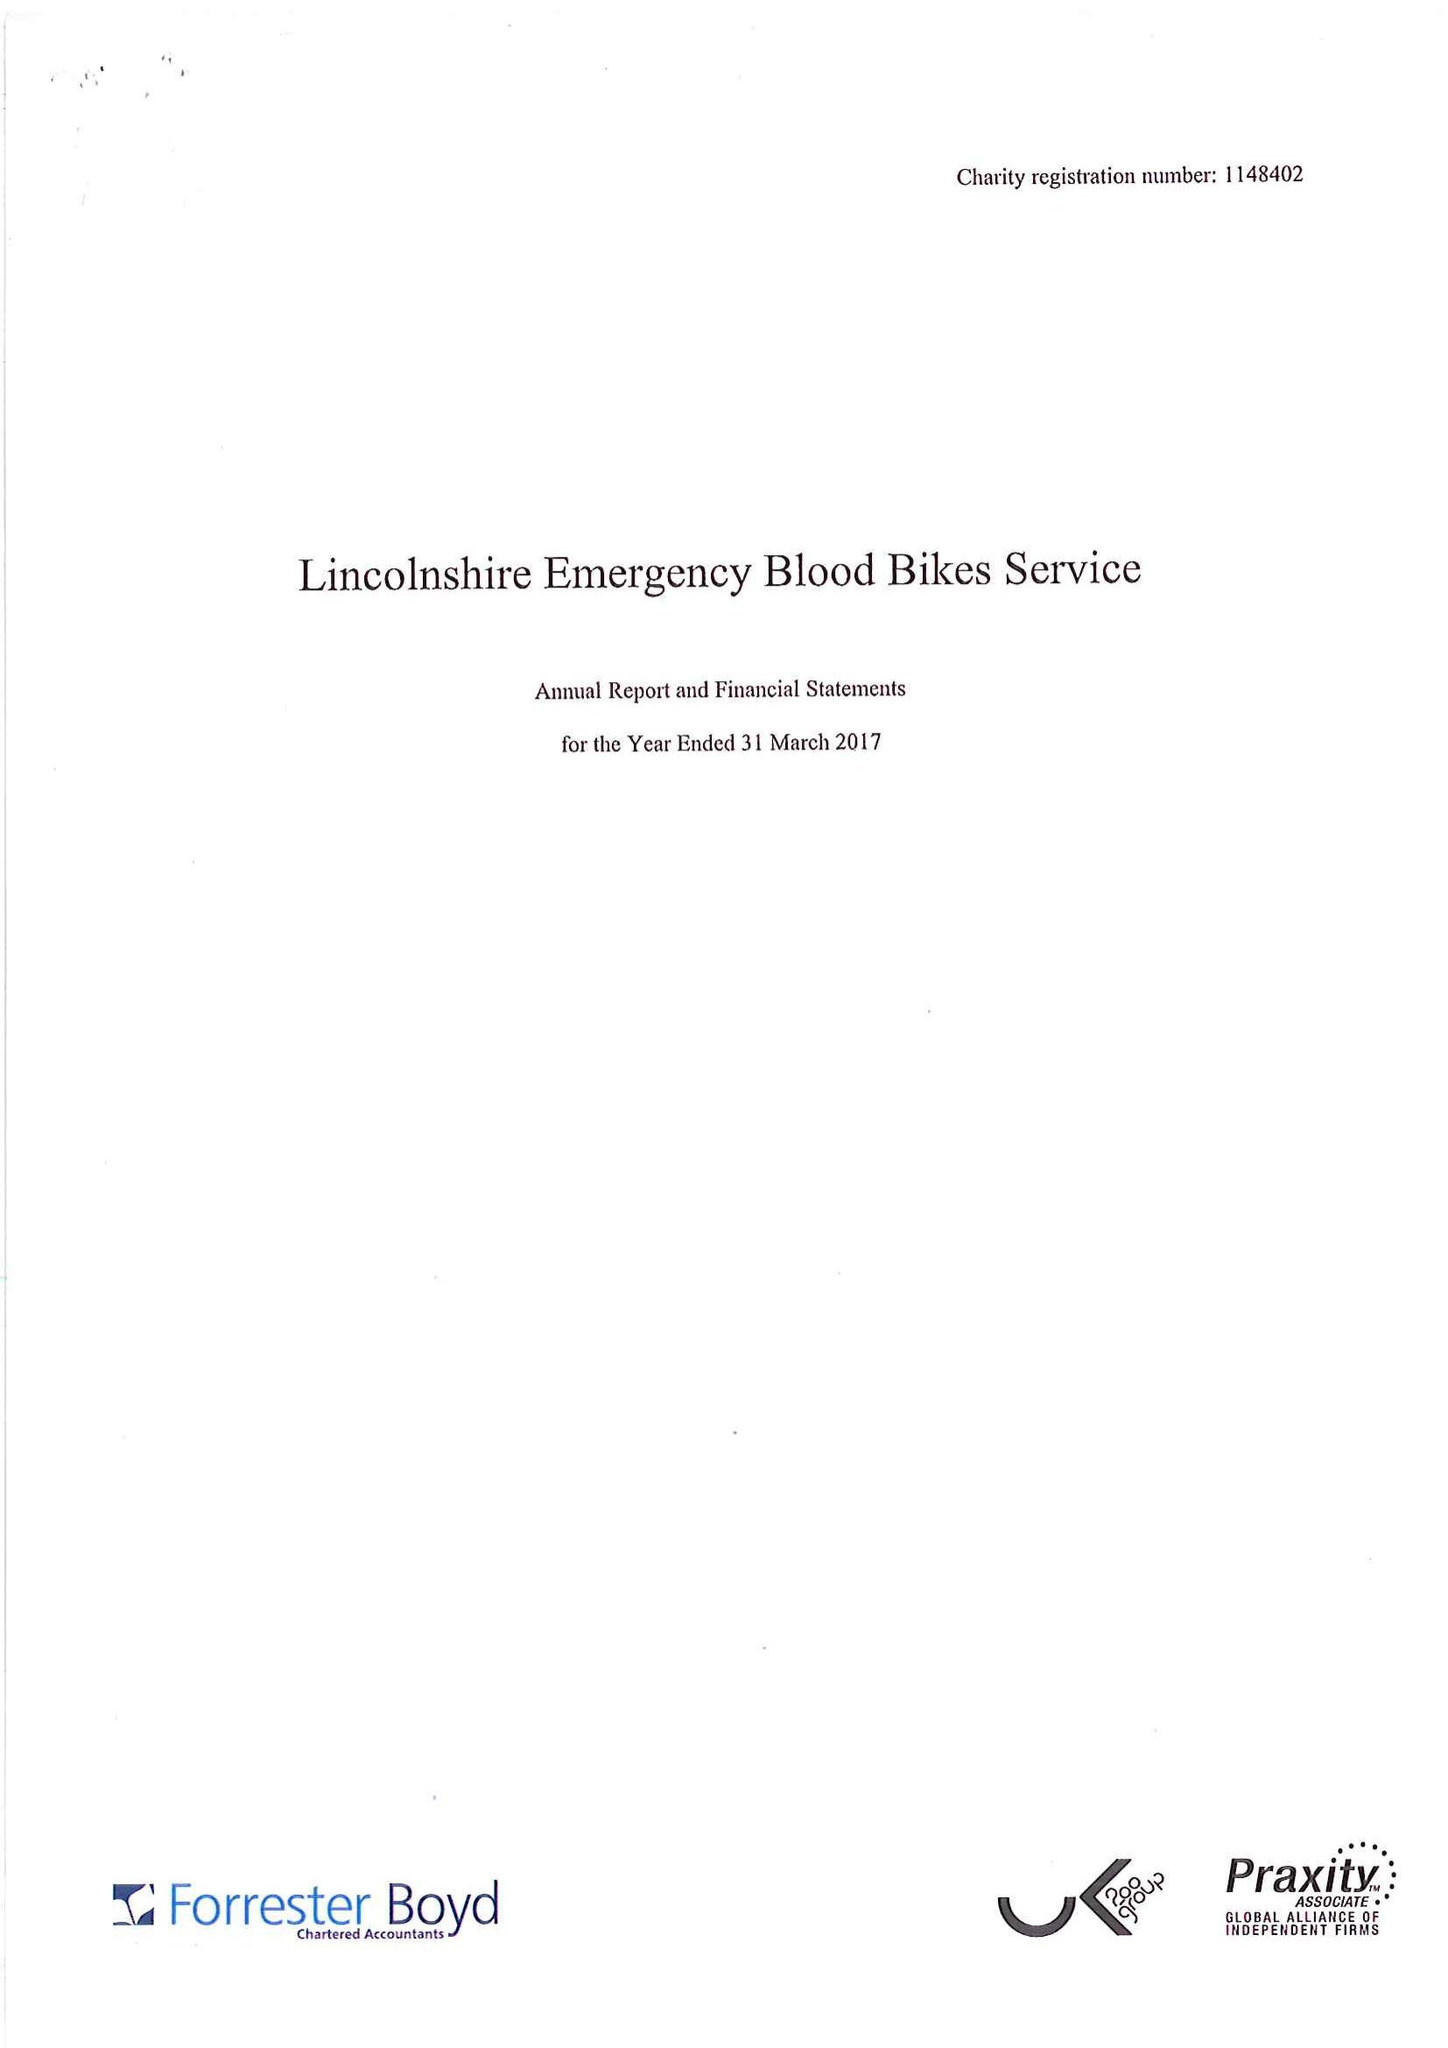What is the value for the address__postcode?
Answer the question using a single word or phrase. LN11 8LQ 